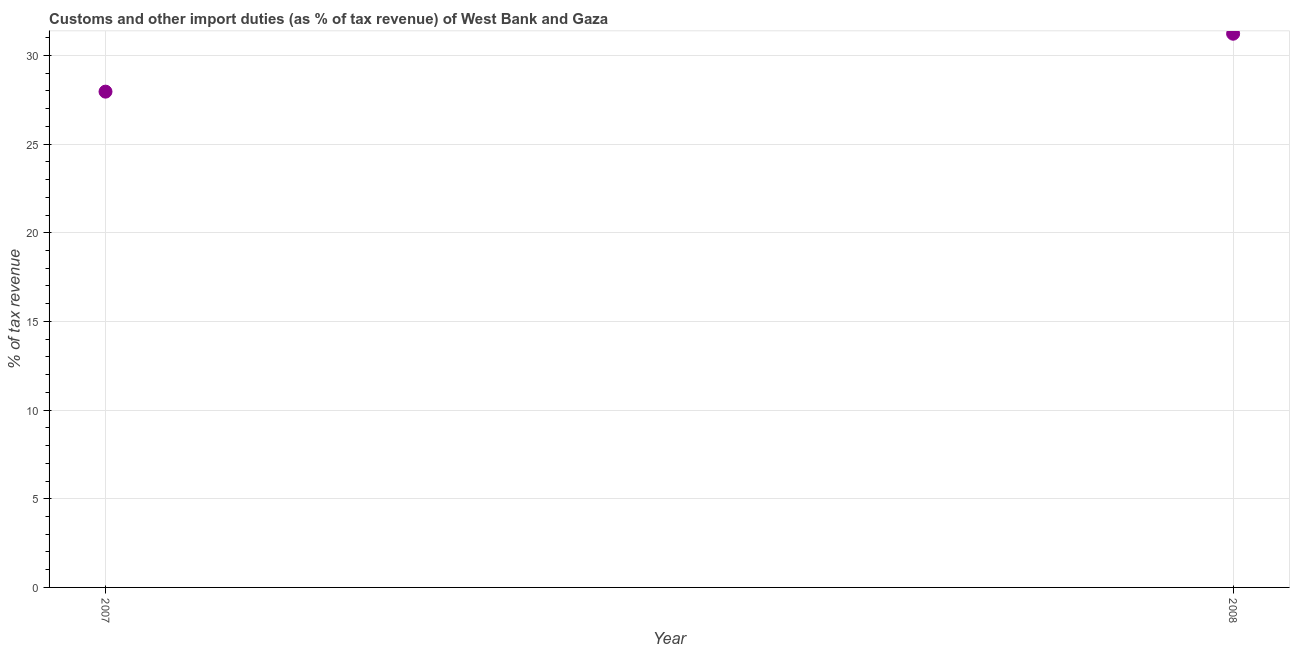What is the customs and other import duties in 2007?
Give a very brief answer. 27.96. Across all years, what is the maximum customs and other import duties?
Make the answer very short. 31.22. Across all years, what is the minimum customs and other import duties?
Provide a short and direct response. 27.96. In which year was the customs and other import duties minimum?
Ensure brevity in your answer.  2007. What is the sum of the customs and other import duties?
Make the answer very short. 59.18. What is the difference between the customs and other import duties in 2007 and 2008?
Your response must be concise. -3.27. What is the average customs and other import duties per year?
Provide a succinct answer. 29.59. What is the median customs and other import duties?
Your answer should be compact. 29.59. Do a majority of the years between 2007 and 2008 (inclusive) have customs and other import duties greater than 23 %?
Give a very brief answer. Yes. What is the ratio of the customs and other import duties in 2007 to that in 2008?
Make the answer very short. 0.9. What is the difference between two consecutive major ticks on the Y-axis?
Provide a short and direct response. 5. Are the values on the major ticks of Y-axis written in scientific E-notation?
Provide a short and direct response. No. Does the graph contain grids?
Ensure brevity in your answer.  Yes. What is the title of the graph?
Offer a terse response. Customs and other import duties (as % of tax revenue) of West Bank and Gaza. What is the label or title of the Y-axis?
Provide a succinct answer. % of tax revenue. What is the % of tax revenue in 2007?
Keep it short and to the point. 27.96. What is the % of tax revenue in 2008?
Make the answer very short. 31.22. What is the difference between the % of tax revenue in 2007 and 2008?
Keep it short and to the point. -3.27. What is the ratio of the % of tax revenue in 2007 to that in 2008?
Make the answer very short. 0.9. 